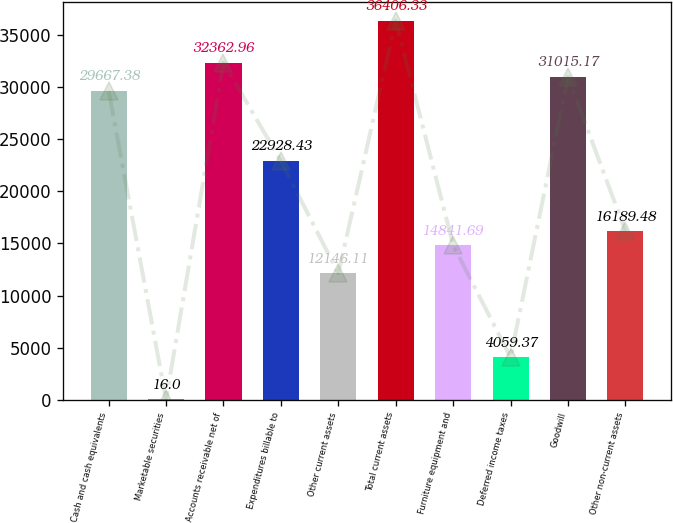<chart> <loc_0><loc_0><loc_500><loc_500><bar_chart><fcel>Cash and cash equivalents<fcel>Marketable securities<fcel>Accounts receivable net of<fcel>Expenditures billable to<fcel>Other current assets<fcel>Total current assets<fcel>Furniture equipment and<fcel>Deferred income taxes<fcel>Goodwill<fcel>Other non-current assets<nl><fcel>29667.4<fcel>16<fcel>32363<fcel>22928.4<fcel>12146.1<fcel>36406.3<fcel>14841.7<fcel>4059.37<fcel>31015.2<fcel>16189.5<nl></chart> 